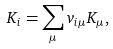<formula> <loc_0><loc_0><loc_500><loc_500>K _ { i } = \sum _ { \mu } v _ { i \mu } K _ { \mu } ,</formula> 